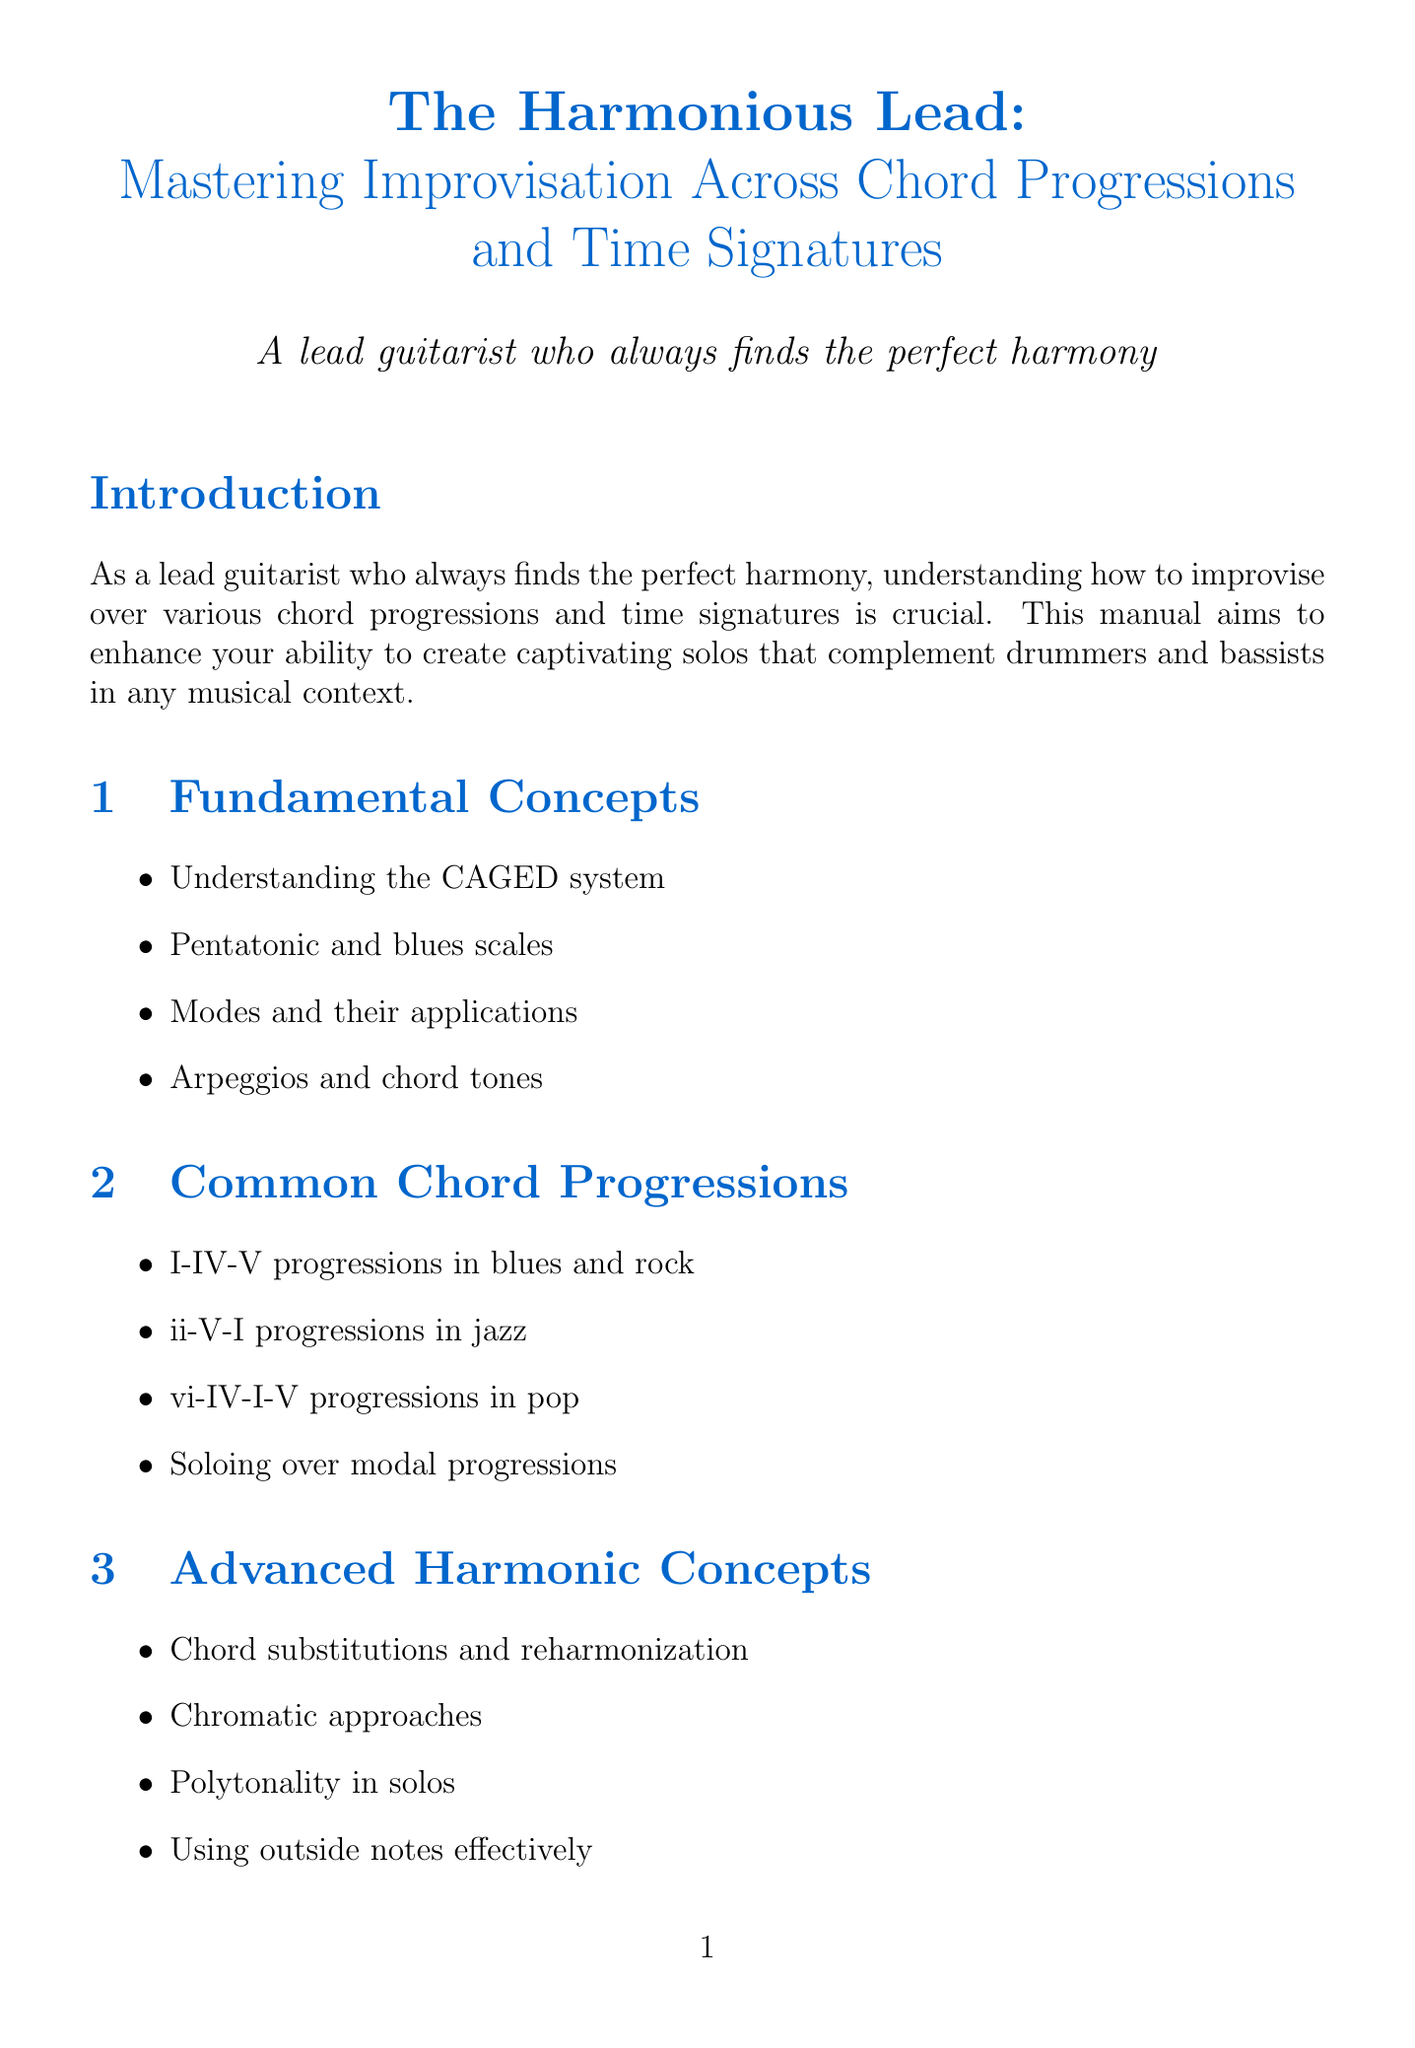What is the title of the manual? The title is printed at the beginning of the document and provides the main focus of the content.
Answer: The Harmonious Lead: Mastering Improvisation Across Chord Progressions and Time Signatures How many chapters are in the manual? The document lists the chapters, and a count of these will reveal the total number.
Answer: Eight What scale is emphasized in the 12-bar blues example? The example specifies the key elements which include particular scales used in the solo.
Answer: A minor pentatonic and A blues scale What time signature is used in the polyrhythmic funk example? The time signature is mentioned specifically when describing the example solos in the document.
Answer: 7/8 Which guitarist is known for innovative blues-rock phrasing? The section on inspirational guitarists lists several and associates them with specific styles.
Answer: Jimi Hendrix What technique is highlighted for jazz in the Genre-Specific Techniques chapter? The document outlines specific techniques for different genres, including jazz.
Answer: Bebop lines and chromaticism How many sections are there in the "Phrasing and Rhythm" chapter? Counting the items in the listed sections reveals the total in that chapter.
Answer: Four What is the first section under "Common Chord Progressions"? The chapters include various sections, and the order is indicated in the table of contents.
Answer: I-IV-V progressions in blues and rock 